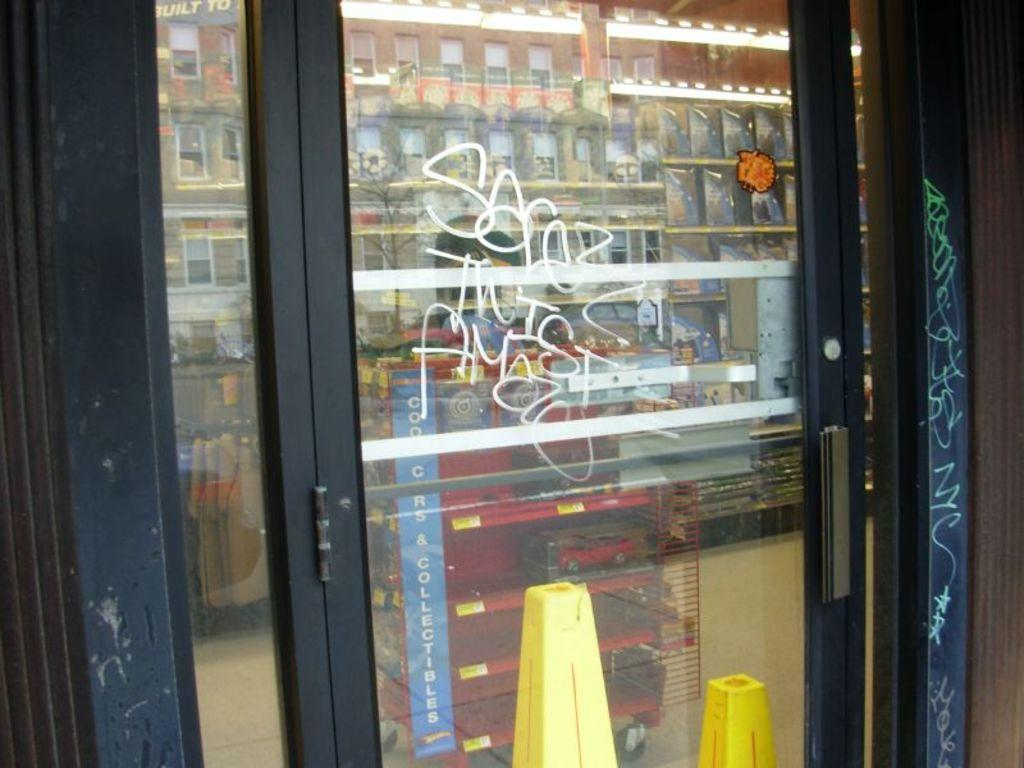What type of door is visible in the image? There is a glass door in the image. What is written or displayed on the glass door? The glass door has text on it. What can be seen through the glass door? Buildings and other objects are visible through the glass door. What type of card is being used to stop the train in the image? There is no train or card present in the image; it only features a glass door with text and a view of buildings and other objects. 